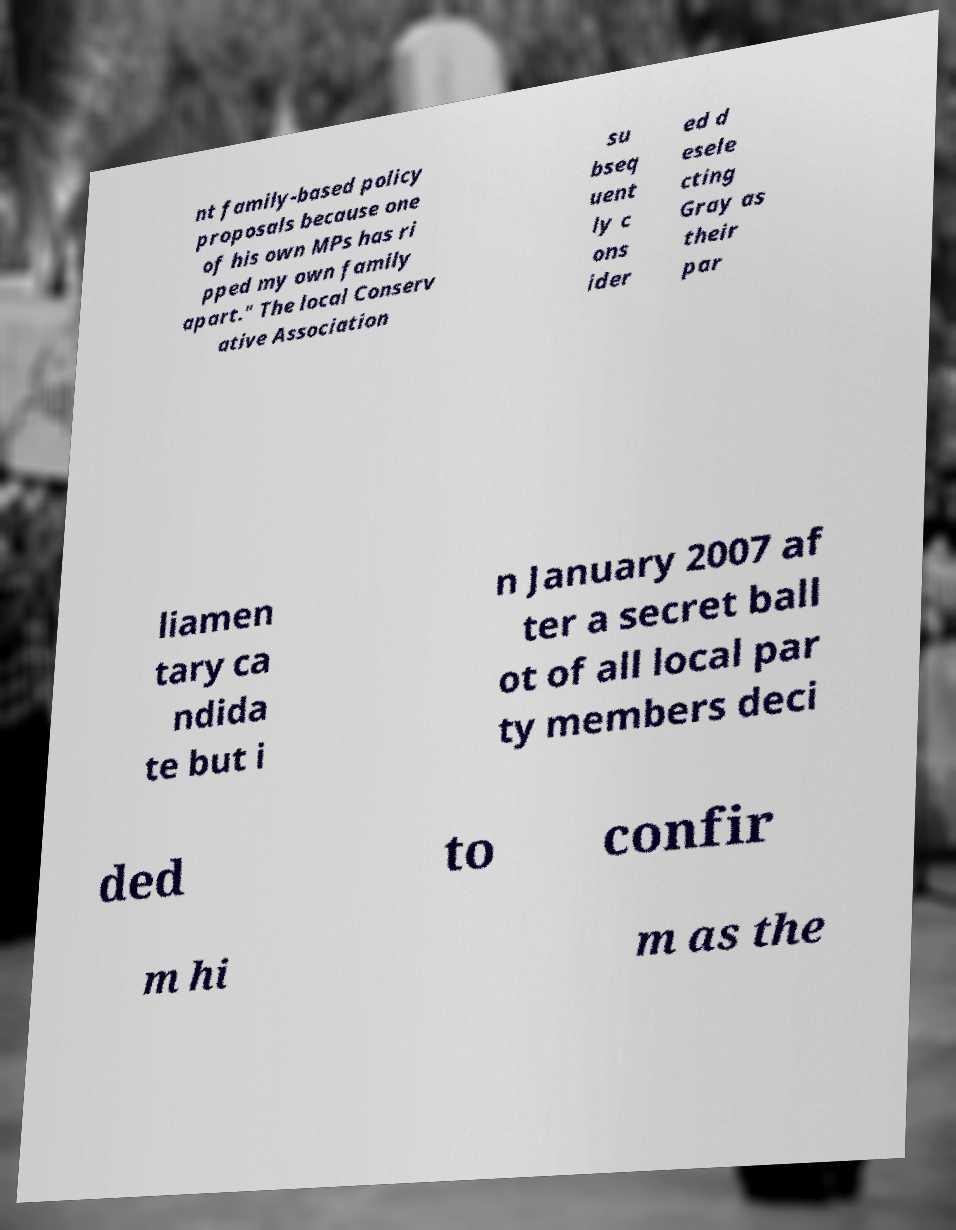I need the written content from this picture converted into text. Can you do that? nt family-based policy proposals because one of his own MPs has ri pped my own family apart." The local Conserv ative Association su bseq uent ly c ons ider ed d esele cting Gray as their par liamen tary ca ndida te but i n January 2007 af ter a secret ball ot of all local par ty members deci ded to confir m hi m as the 